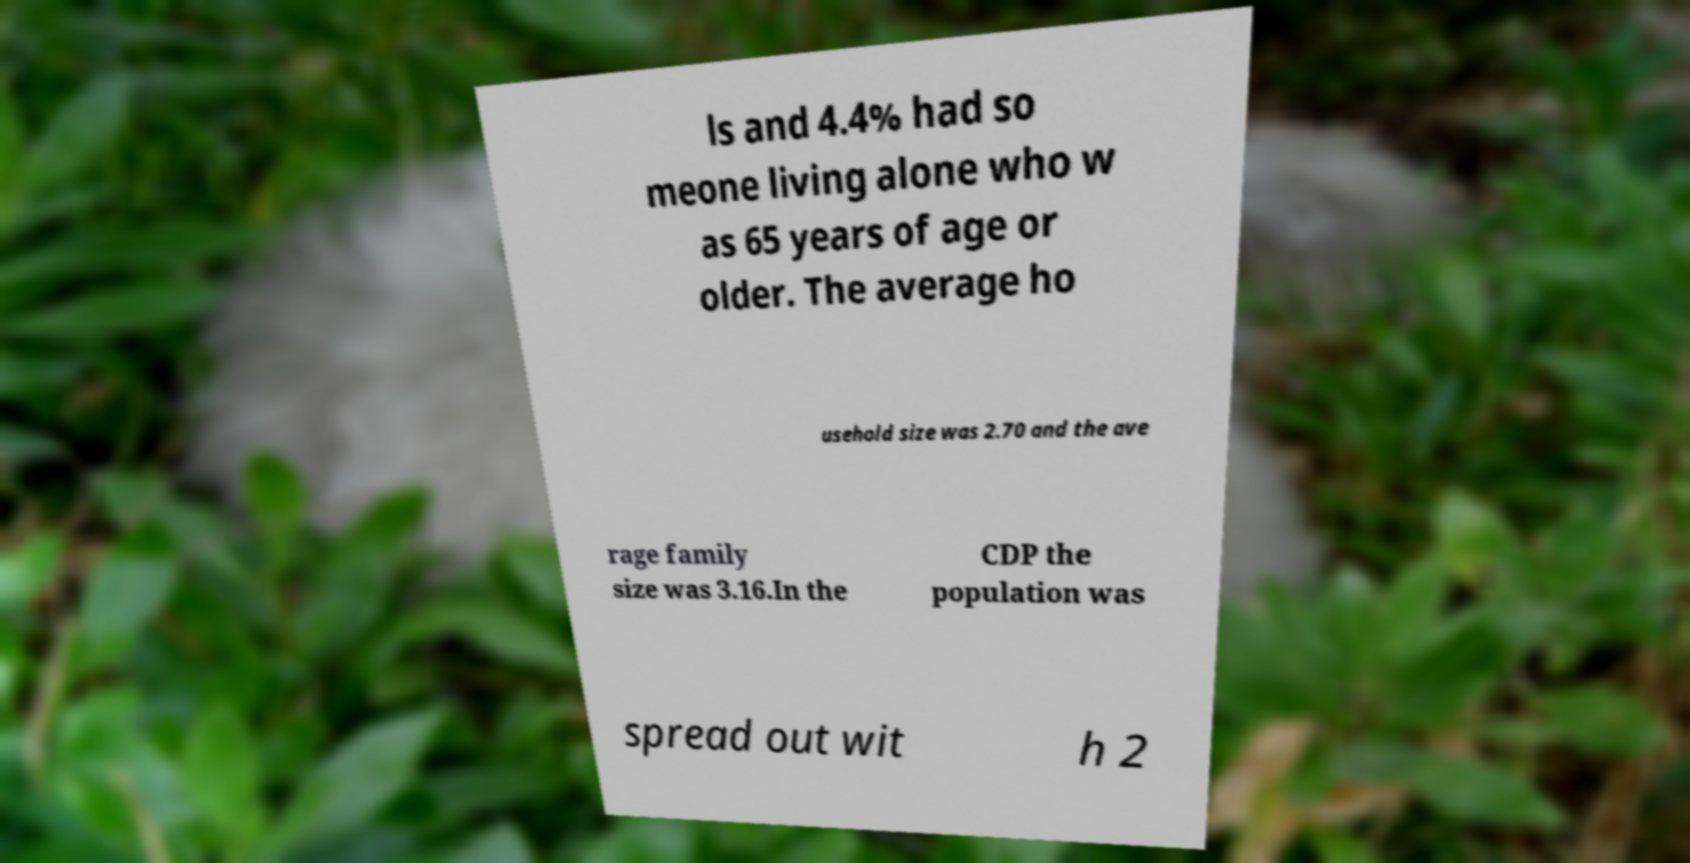Can you accurately transcribe the text from the provided image for me? ls and 4.4% had so meone living alone who w as 65 years of age or older. The average ho usehold size was 2.70 and the ave rage family size was 3.16.In the CDP the population was spread out wit h 2 